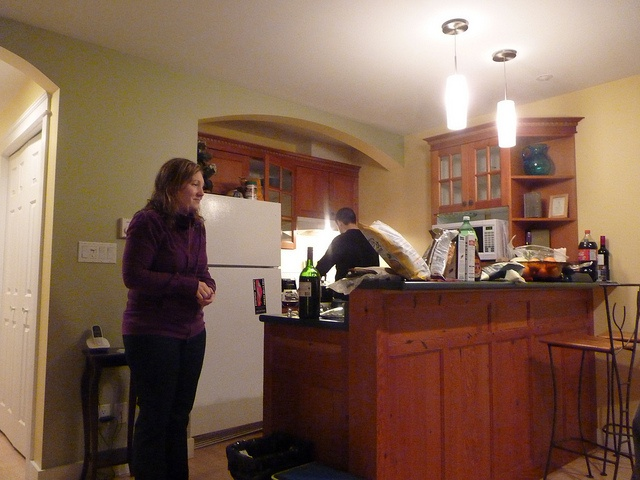Describe the objects in this image and their specific colors. I can see people in gray, black, and maroon tones, refrigerator in gray, darkgray, and tan tones, chair in gray, maroon, and black tones, people in gray and black tones, and microwave in gray, darkgray, and black tones in this image. 